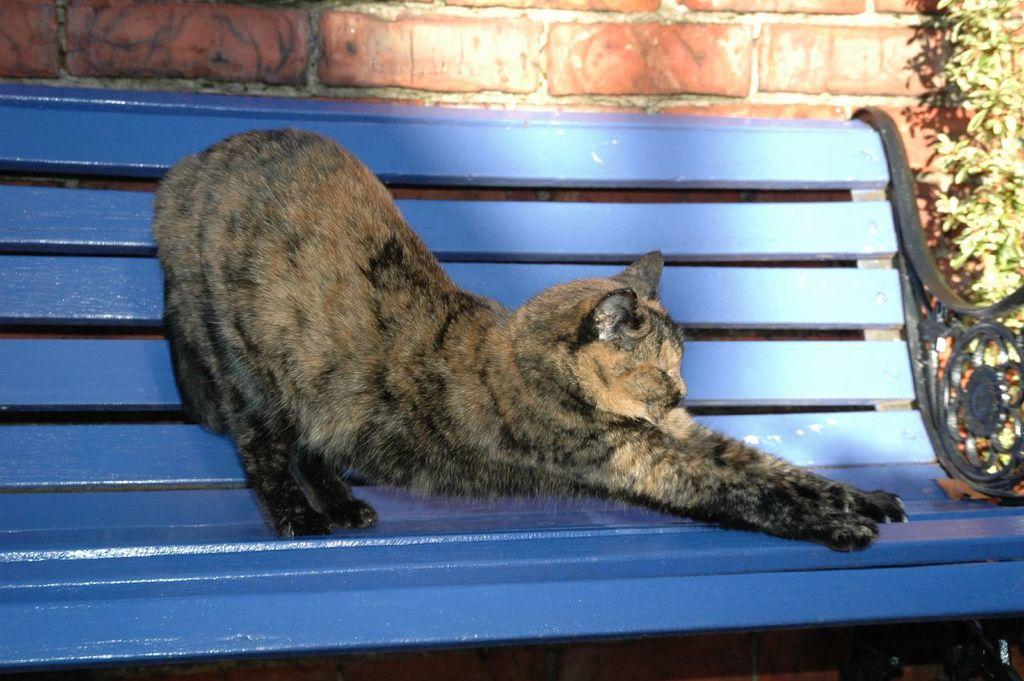What type of animal is in the image? There is a cat in the image. Where is the cat located? The cat is on a bench. What other object can be seen in the image? There is a plant in the image. What type of structure is visible in the image? There is a brick wall in the image. Where is the scarecrow located in the image? There is no scarecrow present in the image. What type of carriage can be seen in the image? There is no carriage present in the image. 